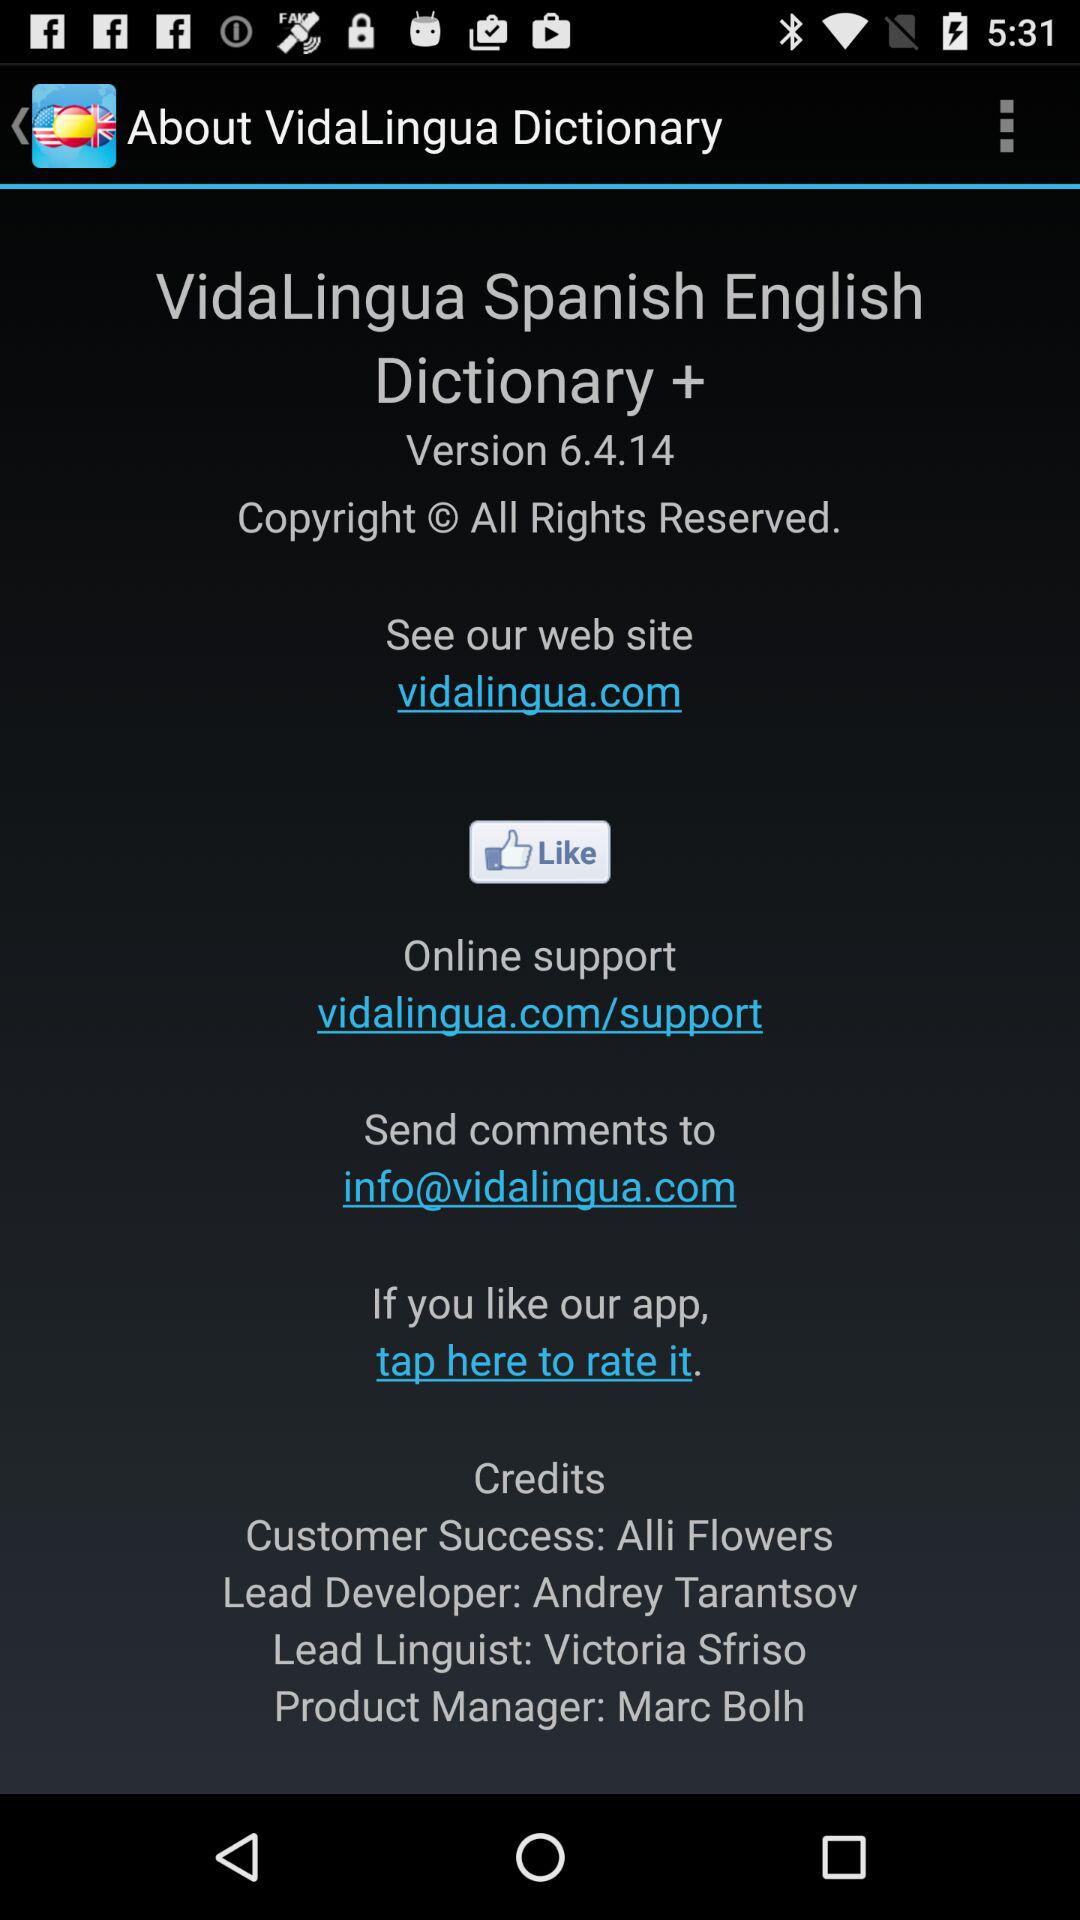What is the preferred language of a dictionary?
When the provided information is insufficient, respond with <no answer>. <no answer> 